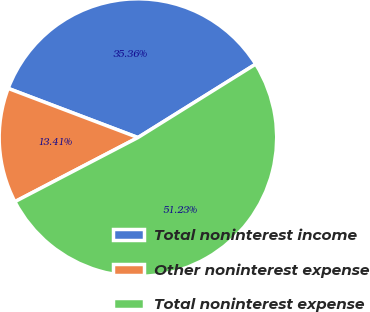Convert chart to OTSL. <chart><loc_0><loc_0><loc_500><loc_500><pie_chart><fcel>Total noninterest income<fcel>Other noninterest expense<fcel>Total noninterest expense<nl><fcel>35.36%<fcel>13.41%<fcel>51.23%<nl></chart> 